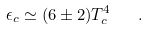Convert formula to latex. <formula><loc_0><loc_0><loc_500><loc_500>\epsilon _ { c } \simeq ( 6 \pm 2 ) T _ { c } ^ { 4 } \quad .</formula> 